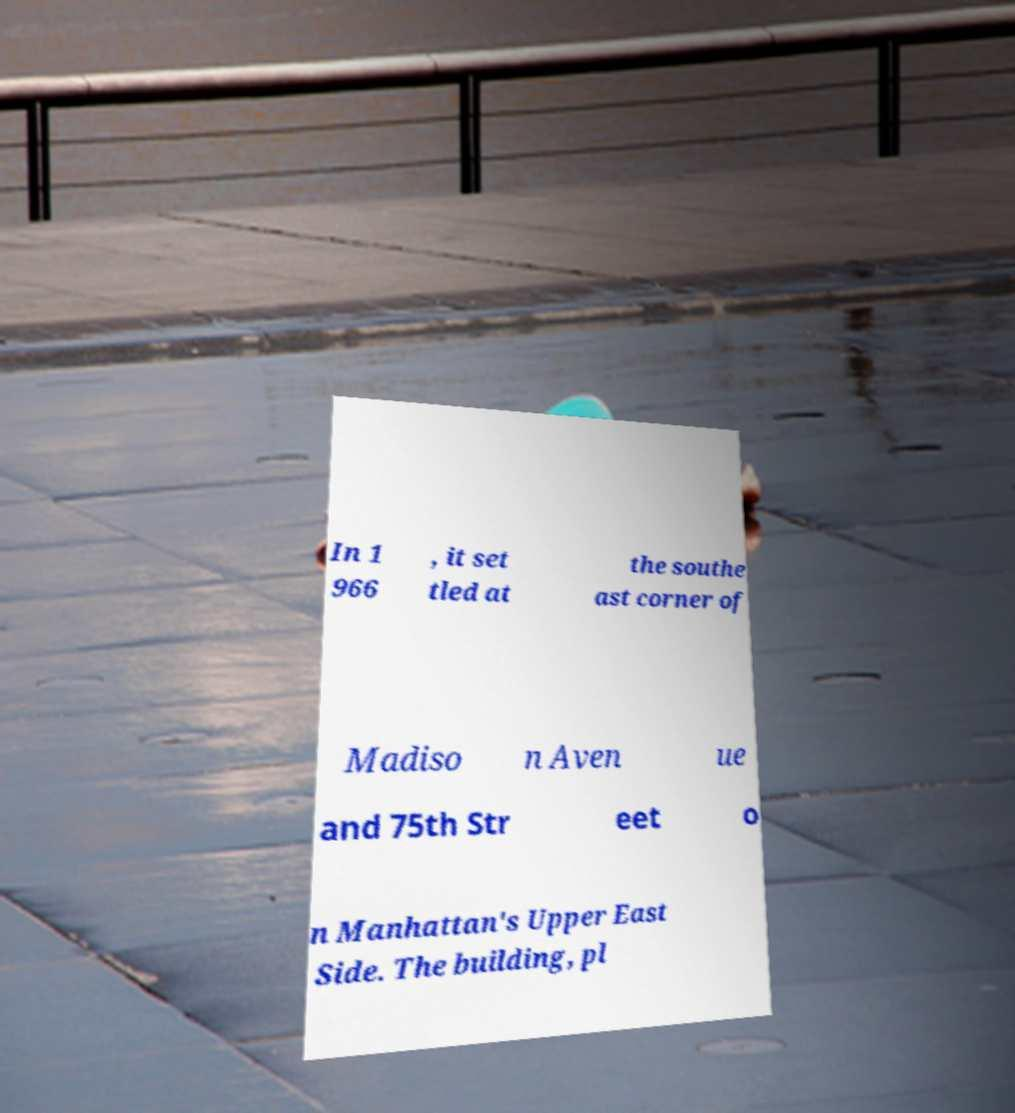Can you read and provide the text displayed in the image?This photo seems to have some interesting text. Can you extract and type it out for me? In 1 966 , it set tled at the southe ast corner of Madiso n Aven ue and 75th Str eet o n Manhattan's Upper East Side. The building, pl 